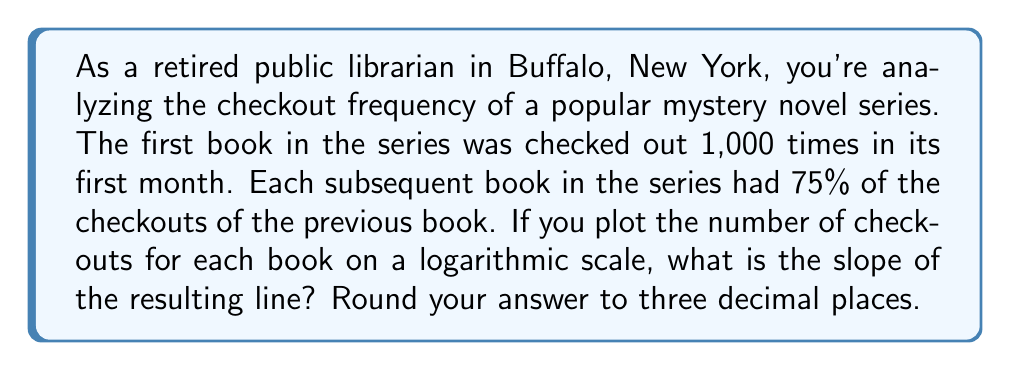Could you help me with this problem? Let's approach this step-by-step:

1) First, let's understand what the data looks like:
   Book 1: 1,000 checkouts
   Book 2: 1,000 * 0.75 = 750 checkouts
   Book 3: 750 * 0.75 = 562.5 checkouts
   And so on...

2) On a logarithmic scale, this forms a straight line. The equation for this line is:

   $$\log y = m\log x + b$$

   Where $y$ is the number of checkouts, $x$ is the book number, $m$ is the slope we're looking for, and $b$ is the y-intercept.

3) To find the slope, we can use the formula:

   $$m = \frac{\log y_2 - \log y_1}{\log x_2 - \log x_1}$$

   Where $(x_1, y_1)$ and $(x_2, y_2)$ are any two points on the line.

4) Let's use the first two books:
   $(x_1, y_1) = (1, 1000)$
   $(x_2, y_2) = (2, 750)$

5) Plugging into the formula:

   $$m = \frac{\log 750 - \log 1000}{\log 2 - \log 1}$$

6) Simplify:
   $$m = \frac{\log 750 - \log 1000}{\log 2}$$

7) Using the logarithm property $\log a - \log b = \log(\frac{a}{b})$:

   $$m = \frac{\log(\frac{750}{1000})}{\log 2} = \frac{\log 0.75}{\log 2}$$

8) Calculate:
   $$m = \frac{-0.12493873660829993}{0.6931471805599453} \approx -0.180$$

9) Rounding to three decimal places: -0.180
Answer: -0.180 